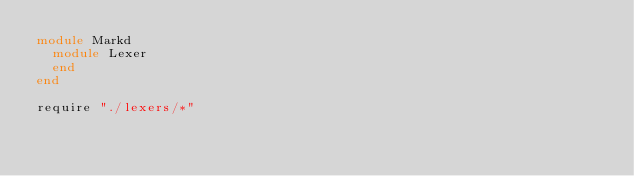Convert code to text. <code><loc_0><loc_0><loc_500><loc_500><_Crystal_>module Markd
  module Lexer
  end
end

require "./lexers/*"
</code> 